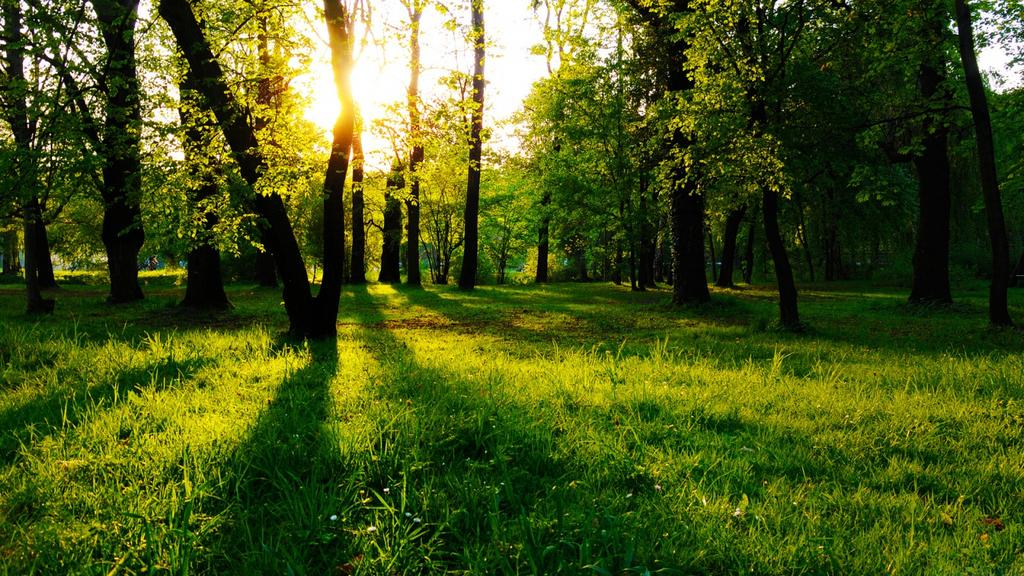What type of vegetation is present in the image? There is grass in the image. What other natural elements can be seen in the image? There are trees in the image. What is visible in the background of the image? The sky is visible in the background of the image. Where is the hole in the image? There is no hole present in the image. What type of zipper can be seen on the trees in the image? There are no zippers present on the trees in the image. 